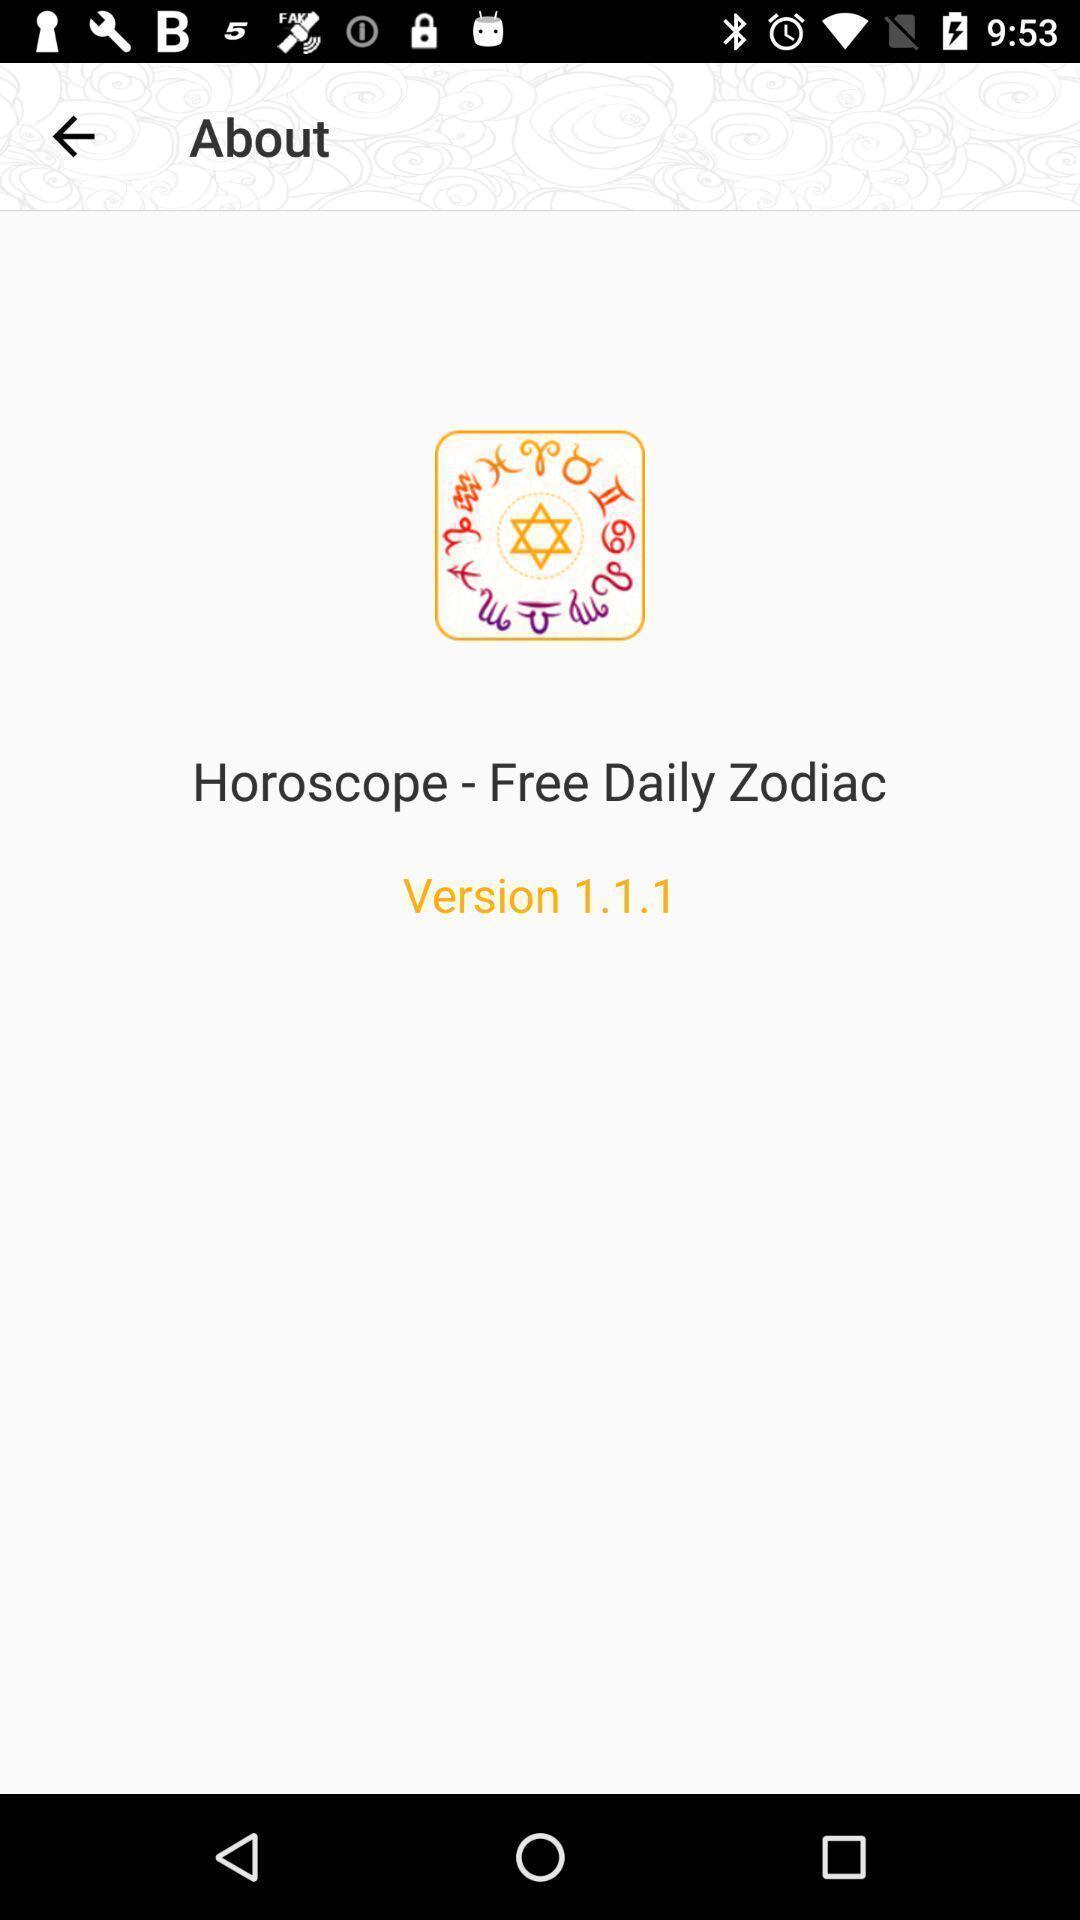Tell me about the visual elements in this screen capture. Screen showing the version. 